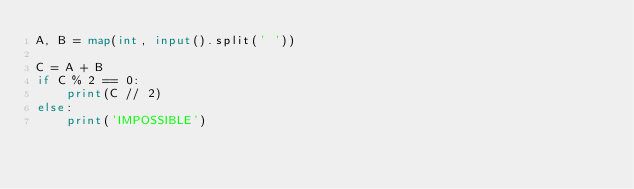Convert code to text. <code><loc_0><loc_0><loc_500><loc_500><_Python_>A, B = map(int, input().split(' '))

C = A + B
if C % 2 == 0:
    print(C // 2)
else:
    print('IMPOSSIBLE')
</code> 